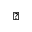<formula> <loc_0><loc_0><loc_500><loc_500>\vartriangle</formula> 